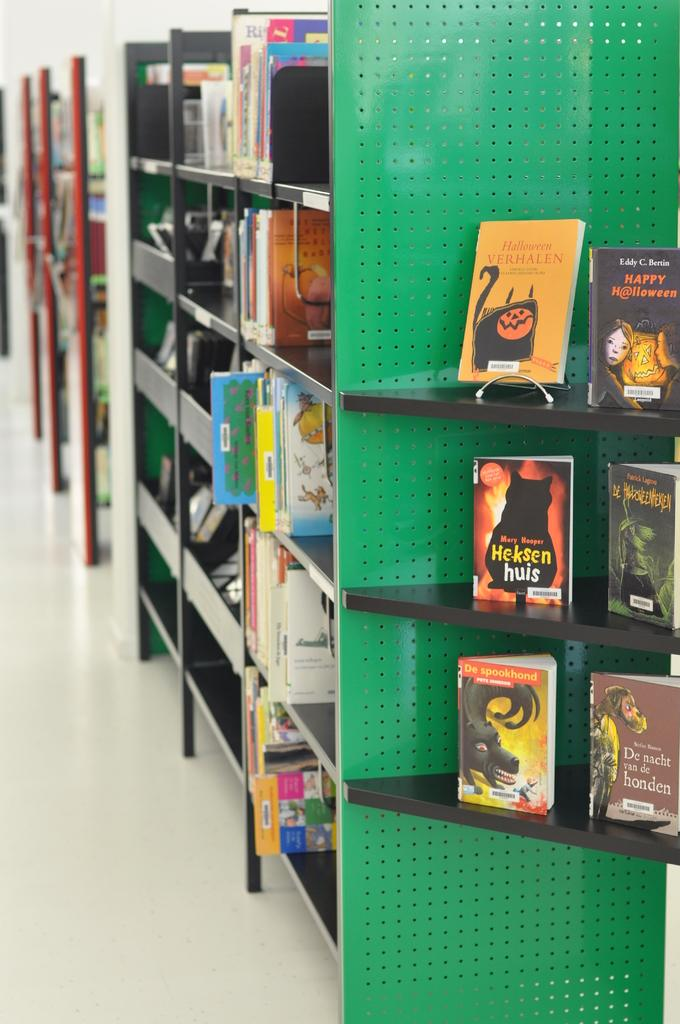<image>
Share a concise interpretation of the image provided. Some Halloween themed books on display including Halloween Verhalen. 